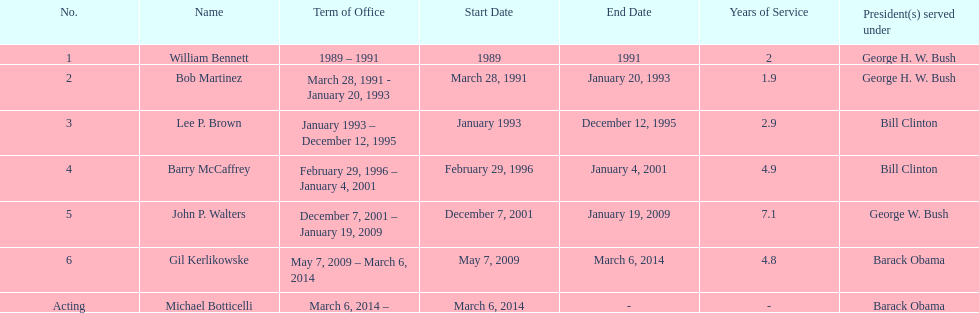Who serves inder barack obama? Gil Kerlikowske. 